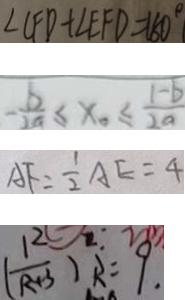Convert formula to latex. <formula><loc_0><loc_0><loc_500><loc_500>\angle C F D + \angle E F D = 1 8 0 ^ { \circ } 
 - \frac { b } { 2 a } \leq x _ { 0 } \leq \frac { 1 - b } { 2 a } 
 A F = \frac { 1 } { 2 } A E = 4 
 ( \frac { R } { R + 3 } ) R = 9 .</formula> 